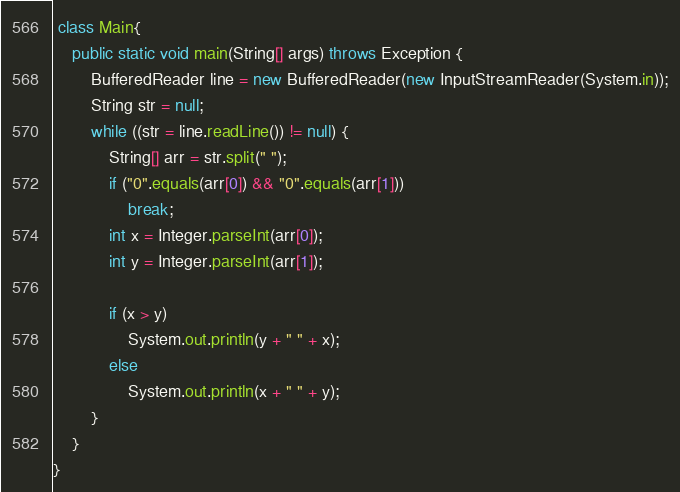Convert code to text. <code><loc_0><loc_0><loc_500><loc_500><_Java_> class Main{
    public static void main(String[] args) throws Exception {
        BufferedReader line = new BufferedReader(new InputStreamReader(System.in));
        String str = null;
        while ((str = line.readLine()) != null) {
            String[] arr = str.split(" ");
            if ("0".equals(arr[0]) && "0".equals(arr[1]))
                break;
            int x = Integer.parseInt(arr[0]);
            int y = Integer.parseInt(arr[1]);
 
            if (x > y)
                System.out.println(y + " " + x);
            else
                System.out.println(x + " " + y);
        }
    }
}</code> 